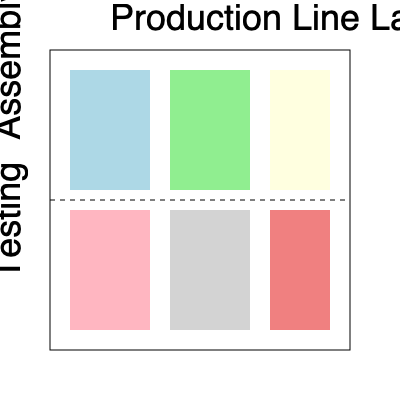Given the factory floor plan shown above, which rearrangement of production areas would likely result in the most efficient battery production process?

A) Swap the positions of the lightblue and lightgreen areas
B) Move the lightyellow area between the lightblue and lightgreen areas
C) Relocate the lightcoral area to be adjacent to the lightblue area
D) Exchange the positions of the lightpink and lightgray areas To determine the most efficient arrangement for battery production, we need to consider the typical flow of a battery manufacturing process:

1. The process usually starts with component preparation and assembly.
2. After assembly, batteries typically undergo initial testing.
3. Final testing and quality control are usually the last steps before packaging.

Analyzing the current layout:

1. The top row (lightblue, lightgreen, lightyellow) represents the assembly areas.
2. The bottom row (lightpink, lightgray, lightcoral) represents the testing areas.
3. The current layout suggests a linear flow from left to right in both rows.

Evaluating the options:

A) Swapping lightblue and lightgreen areas would not significantly improve efficiency as they are both in the assembly row.

B) Moving the lightyellow area between lightblue and lightgreen would disrupt the linear flow and likely decrease efficiency.

C) Relocating the lightcoral area (final testing) to be adjacent to the lightblue area (initial assembly) would create an inefficient back-and-forth movement.

D) Exchanging lightpink and lightgray areas in the testing row would create a more logical flow:
   - lightpink (likely initial testing) would be directly below lightblue and lightgreen (assembly areas)
   - lightgray (intermediate testing) would be in the middle
   - lightcoral (final testing) would remain at the end of the process

Option D provides the most efficient arrangement by aligning the testing processes more closely with their corresponding assembly stages, minimizing unnecessary movement and optimizing the production flow.
Answer: D 